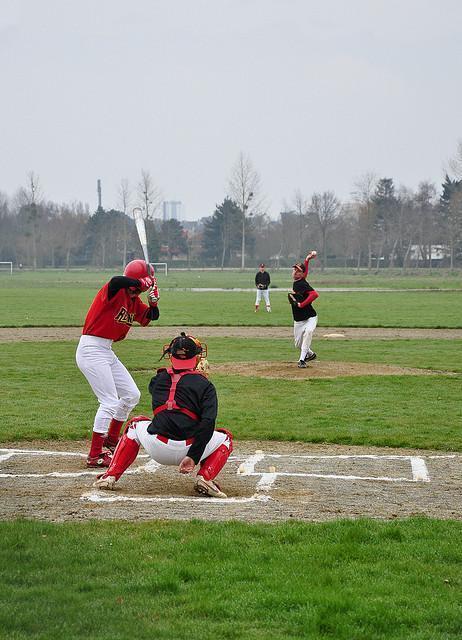What is the opposite form of this pitch?
Choose the correct response and explain in the format: 'Answer: answer
Rationale: rationale.'
Options: Lefthand, sidehand, underhand, overhand. Answer: underhand.
Rationale: Most all pitchers in baseball throw overhand, so the opposite is under. 